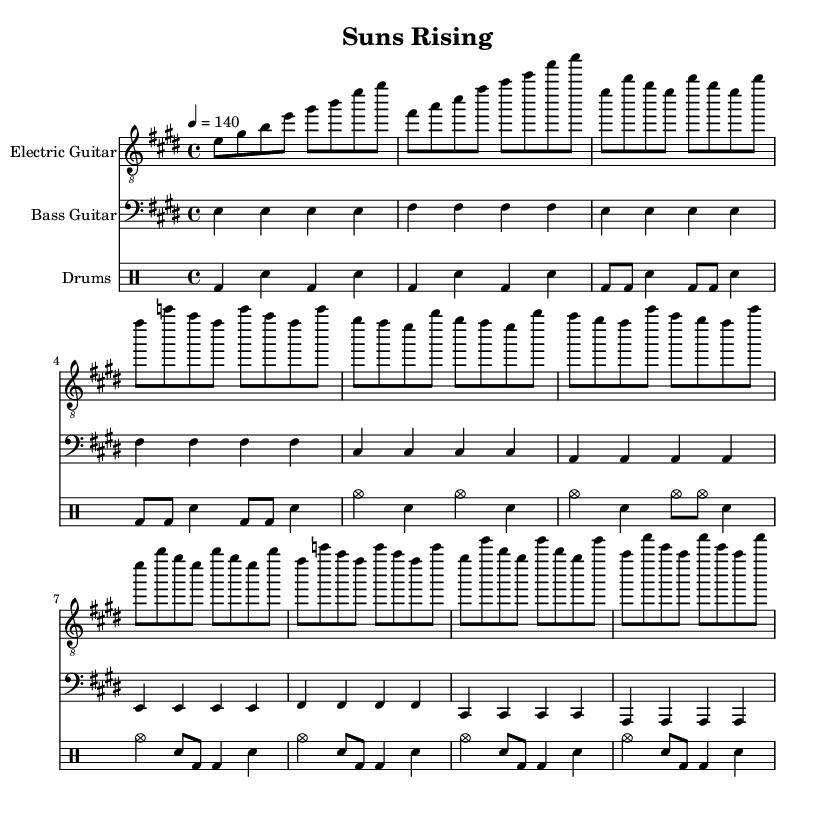What is the key signature of this music? The key signature is E major, which has four sharps: F sharp, C sharp, G sharp, and D sharp. This can be determined from the beginning of the score where the sharps are noted.
Answer: E major What is the time signature of this music? The time signature is 4/4, which is indicated at the beginning of the score. This means there are four beats in a measure, and the quarter note gets one beat.
Answer: 4/4 What is the tempo marking for this piece? The tempo marking is quarter note = 140, which is indicated at the beginning of the score. This means that there are 140 quarter notes played per minute, indicating a fast-paced song.
Answer: 140 How many measures are in the chorus? The chorus consists of four measures; by counting the measures in the section labeled as the chorus (shown visually in the sheet music), we see it spans from the start to the end of four musical statements.
Answer: 4 What rhythm pattern is used in the verse for the electric guitar? The electric guitar in the verse uses an eighth note rhythm pattern, alternating between the notes indicated. This is visually evident from the way the notes are structured and spaced within the measures.
Answer: Eighth note rhythm What type of drum pattern does the introduction follow? The introduction follows a simple kick-snare pattern with bass drums and snare hits forming a rhythmic base. This can be derived from the specific beats indicated in the drum notation.
Answer: Kick-snare pattern What is the instrument primarily used for the melody in this piece? The instrument primarily used for the melody is the electric guitar, as it has the main melodic lines written in the treble clef at the top of the score.
Answer: Electric guitar 